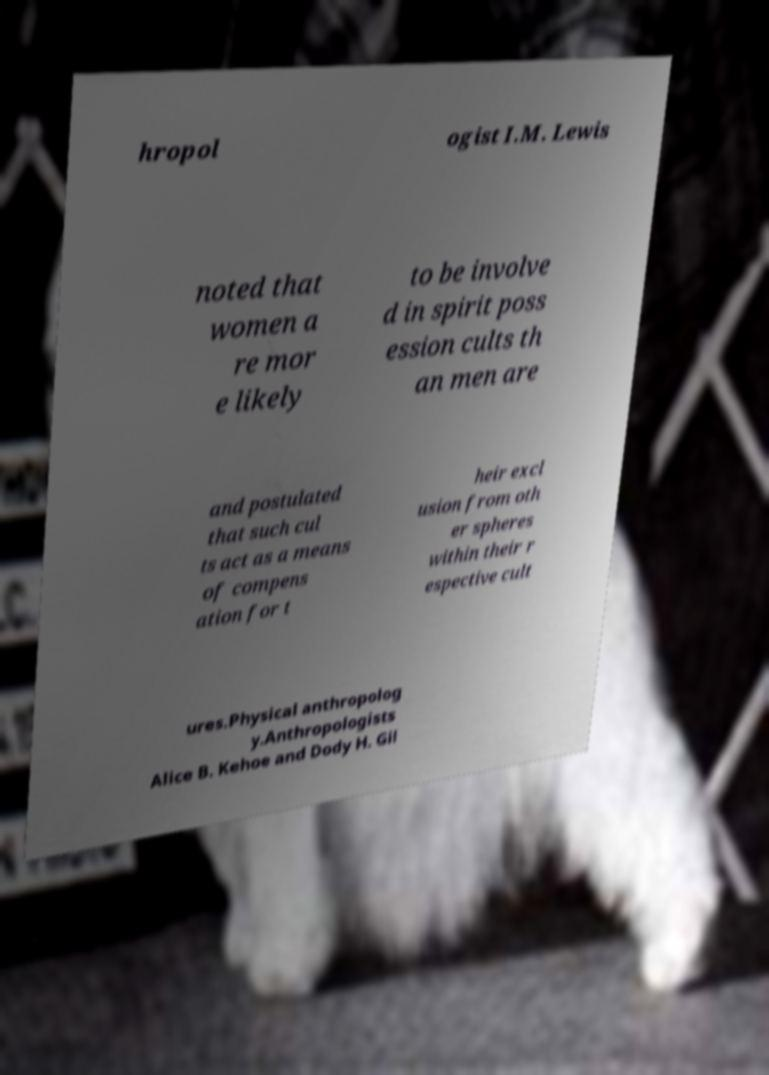Please identify and transcribe the text found in this image. hropol ogist I.M. Lewis noted that women a re mor e likely to be involve d in spirit poss ession cults th an men are and postulated that such cul ts act as a means of compens ation for t heir excl usion from oth er spheres within their r espective cult ures.Physical anthropolog y.Anthropologists Alice B. Kehoe and Dody H. Gil 